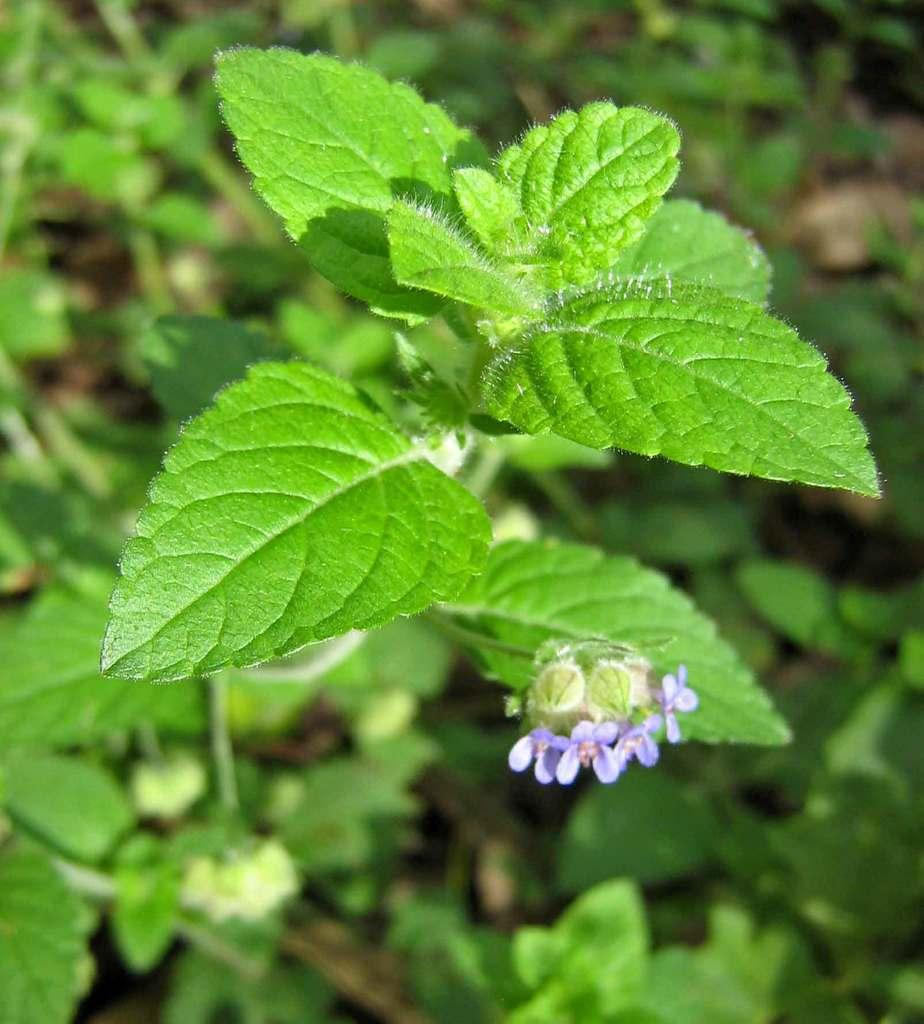What type of living organism can be seen in the image? There is a plant in the image. What color are the leaves of the plant? The plant has green leaves. What color are the flowers of the plant? The plant has blue flowers. Can you describe the background of the image? The background of the image is blurred. How many pairs of scissors can be seen in the image? There are no scissors present in the image. What type of snake is visible in the image? There are no snakes present in the image. 